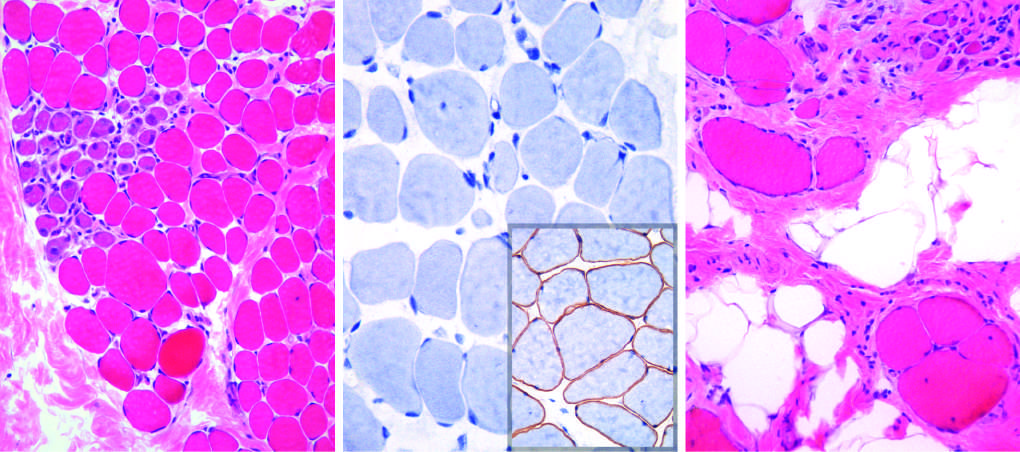does gland illustrate disease progression, which is marked by extensive variation in myofiber size, fatty replacement, and endomysial fibrosis in (c)?
Answer the question using a single word or phrase. No 